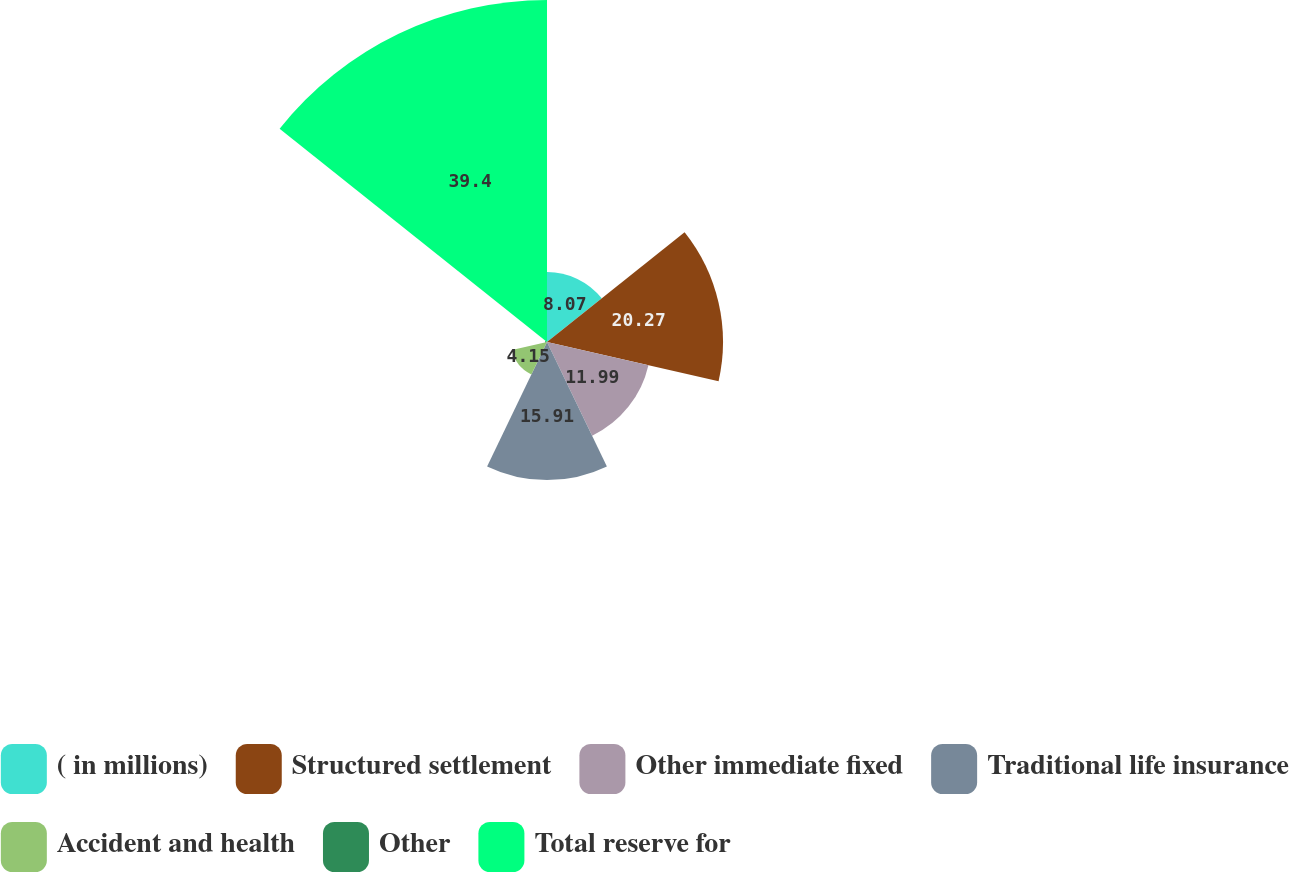<chart> <loc_0><loc_0><loc_500><loc_500><pie_chart><fcel>( in millions)<fcel>Structured settlement<fcel>Other immediate fixed<fcel>Traditional life insurance<fcel>Accident and health<fcel>Other<fcel>Total reserve for<nl><fcel>8.07%<fcel>20.28%<fcel>11.99%<fcel>15.91%<fcel>4.15%<fcel>0.21%<fcel>39.41%<nl></chart> 